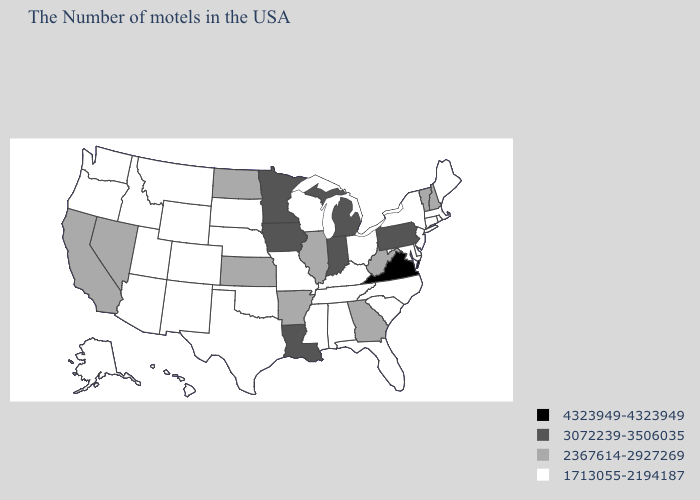Among the states that border Arkansas , which have the lowest value?
Concise answer only. Tennessee, Mississippi, Missouri, Oklahoma, Texas. Among the states that border Florida , does Alabama have the highest value?
Be succinct. No. What is the value of Tennessee?
Keep it brief. 1713055-2194187. What is the highest value in states that border Washington?
Quick response, please. 1713055-2194187. What is the value of Massachusetts?
Give a very brief answer. 1713055-2194187. What is the value of Iowa?
Write a very short answer. 3072239-3506035. What is the value of Virginia?
Give a very brief answer. 4323949-4323949. Name the states that have a value in the range 3072239-3506035?
Answer briefly. Pennsylvania, Michigan, Indiana, Louisiana, Minnesota, Iowa. How many symbols are there in the legend?
Answer briefly. 4. What is the value of Maryland?
Quick response, please. 1713055-2194187. Which states have the lowest value in the MidWest?
Give a very brief answer. Ohio, Wisconsin, Missouri, Nebraska, South Dakota. Name the states that have a value in the range 1713055-2194187?
Write a very short answer. Maine, Massachusetts, Rhode Island, Connecticut, New York, New Jersey, Delaware, Maryland, North Carolina, South Carolina, Ohio, Florida, Kentucky, Alabama, Tennessee, Wisconsin, Mississippi, Missouri, Nebraska, Oklahoma, Texas, South Dakota, Wyoming, Colorado, New Mexico, Utah, Montana, Arizona, Idaho, Washington, Oregon, Alaska, Hawaii. What is the highest value in states that border North Dakota?
Be succinct. 3072239-3506035. Which states have the lowest value in the South?
Quick response, please. Delaware, Maryland, North Carolina, South Carolina, Florida, Kentucky, Alabama, Tennessee, Mississippi, Oklahoma, Texas. Does the first symbol in the legend represent the smallest category?
Be succinct. No. 